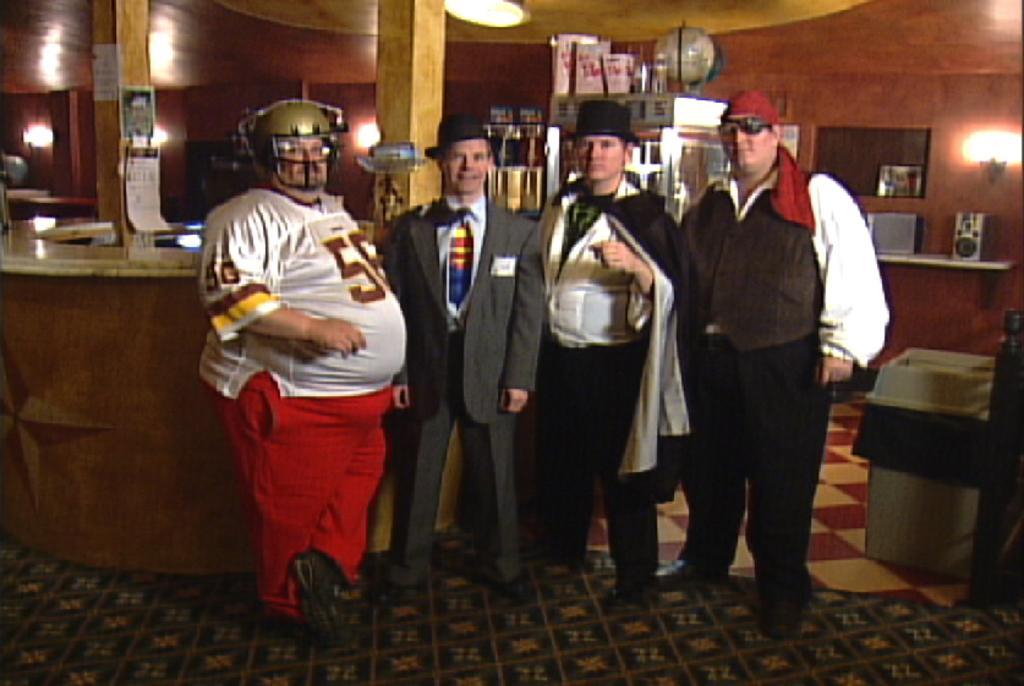Describe this image in one or two sentences. In this image, we can see lights and wooden pillars. There are some objects at the top of the image. There are four persons in the middle of the image standing in front of the counter. There is a wall shelf on the right side of the image contains a speaker. There is a trash bin in the bottom right of the image. 